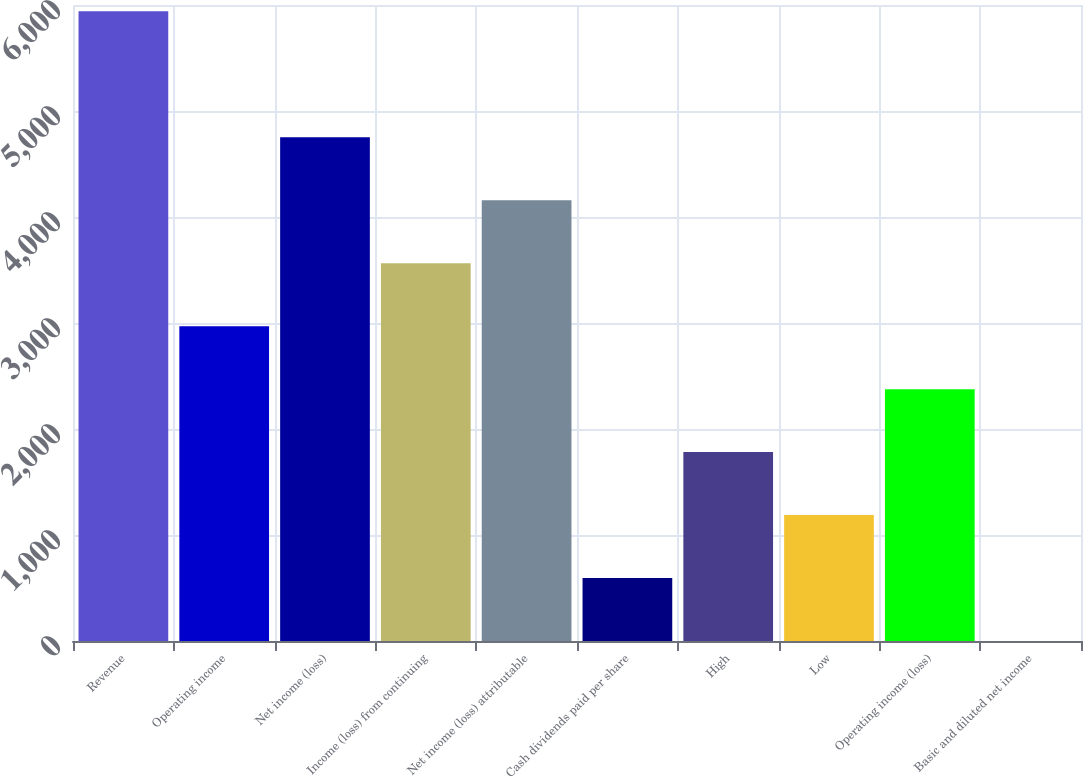<chart> <loc_0><loc_0><loc_500><loc_500><bar_chart><fcel>Revenue<fcel>Operating income<fcel>Net income (loss)<fcel>Income (loss) from continuing<fcel>Net income (loss) attributable<fcel>Cash dividends paid per share<fcel>High<fcel>Low<fcel>Operating income (loss)<fcel>Basic and diluted net income<nl><fcel>5940<fcel>2970.07<fcel>4752.01<fcel>3564.05<fcel>4158.03<fcel>594.15<fcel>1782.11<fcel>1188.13<fcel>2376.09<fcel>0.17<nl></chart> 